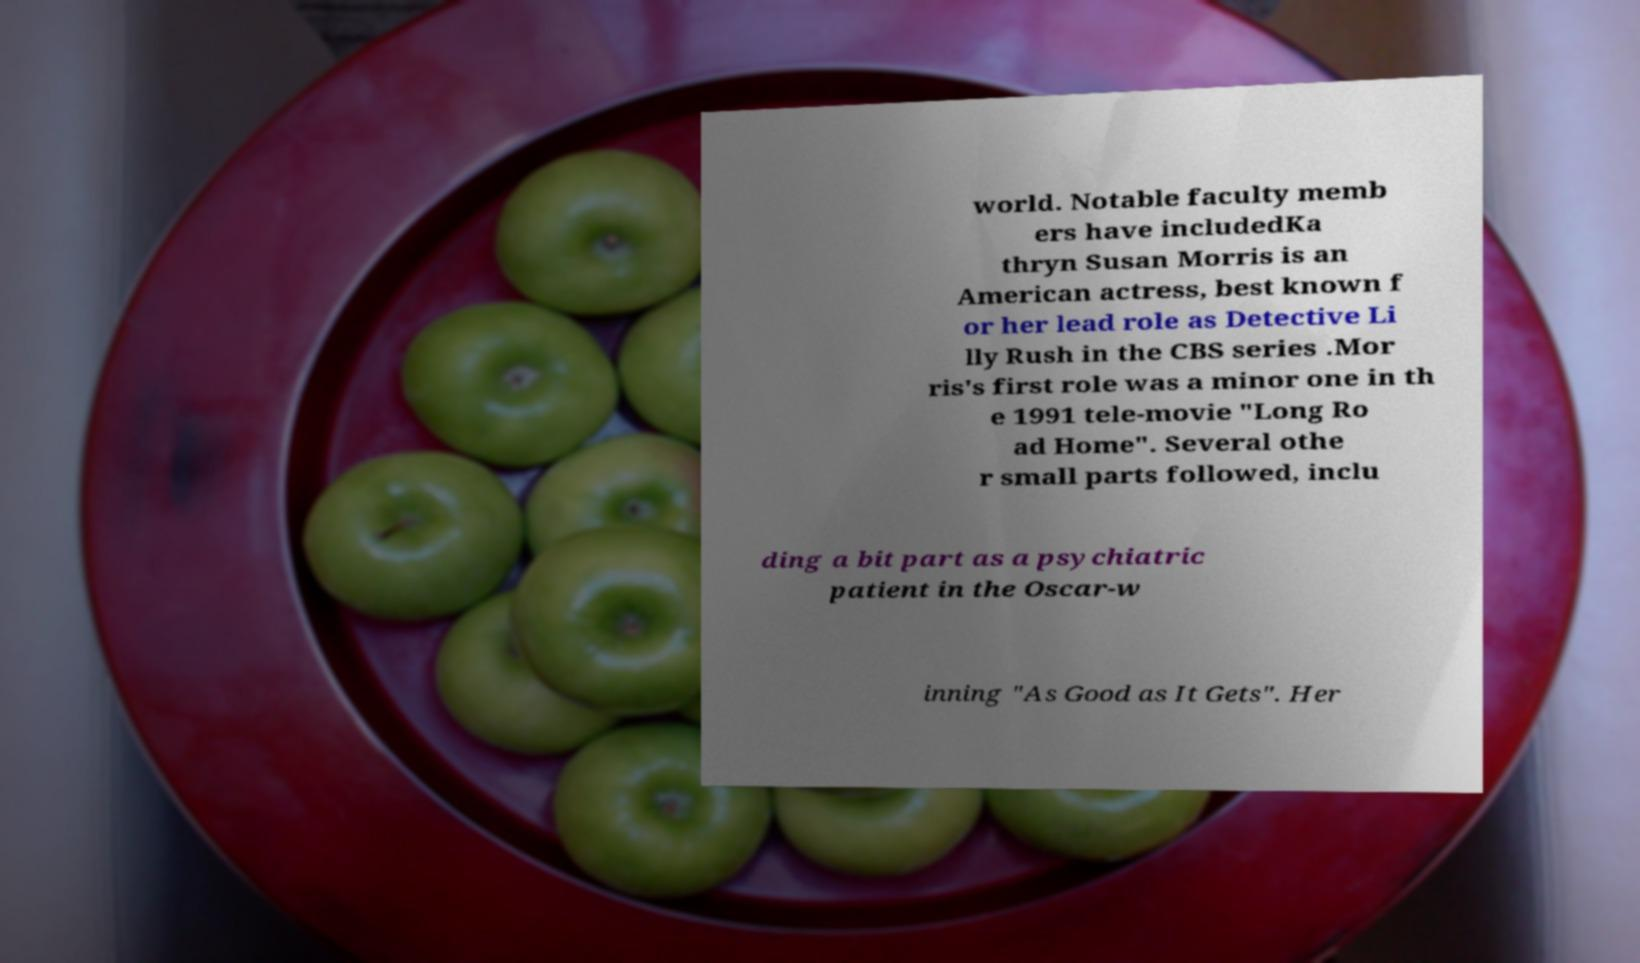I need the written content from this picture converted into text. Can you do that? world. Notable faculty memb ers have includedKa thryn Susan Morris is an American actress, best known f or her lead role as Detective Li lly Rush in the CBS series .Mor ris's first role was a minor one in th e 1991 tele-movie "Long Ro ad Home". Several othe r small parts followed, inclu ding a bit part as a psychiatric patient in the Oscar-w inning "As Good as It Gets". Her 